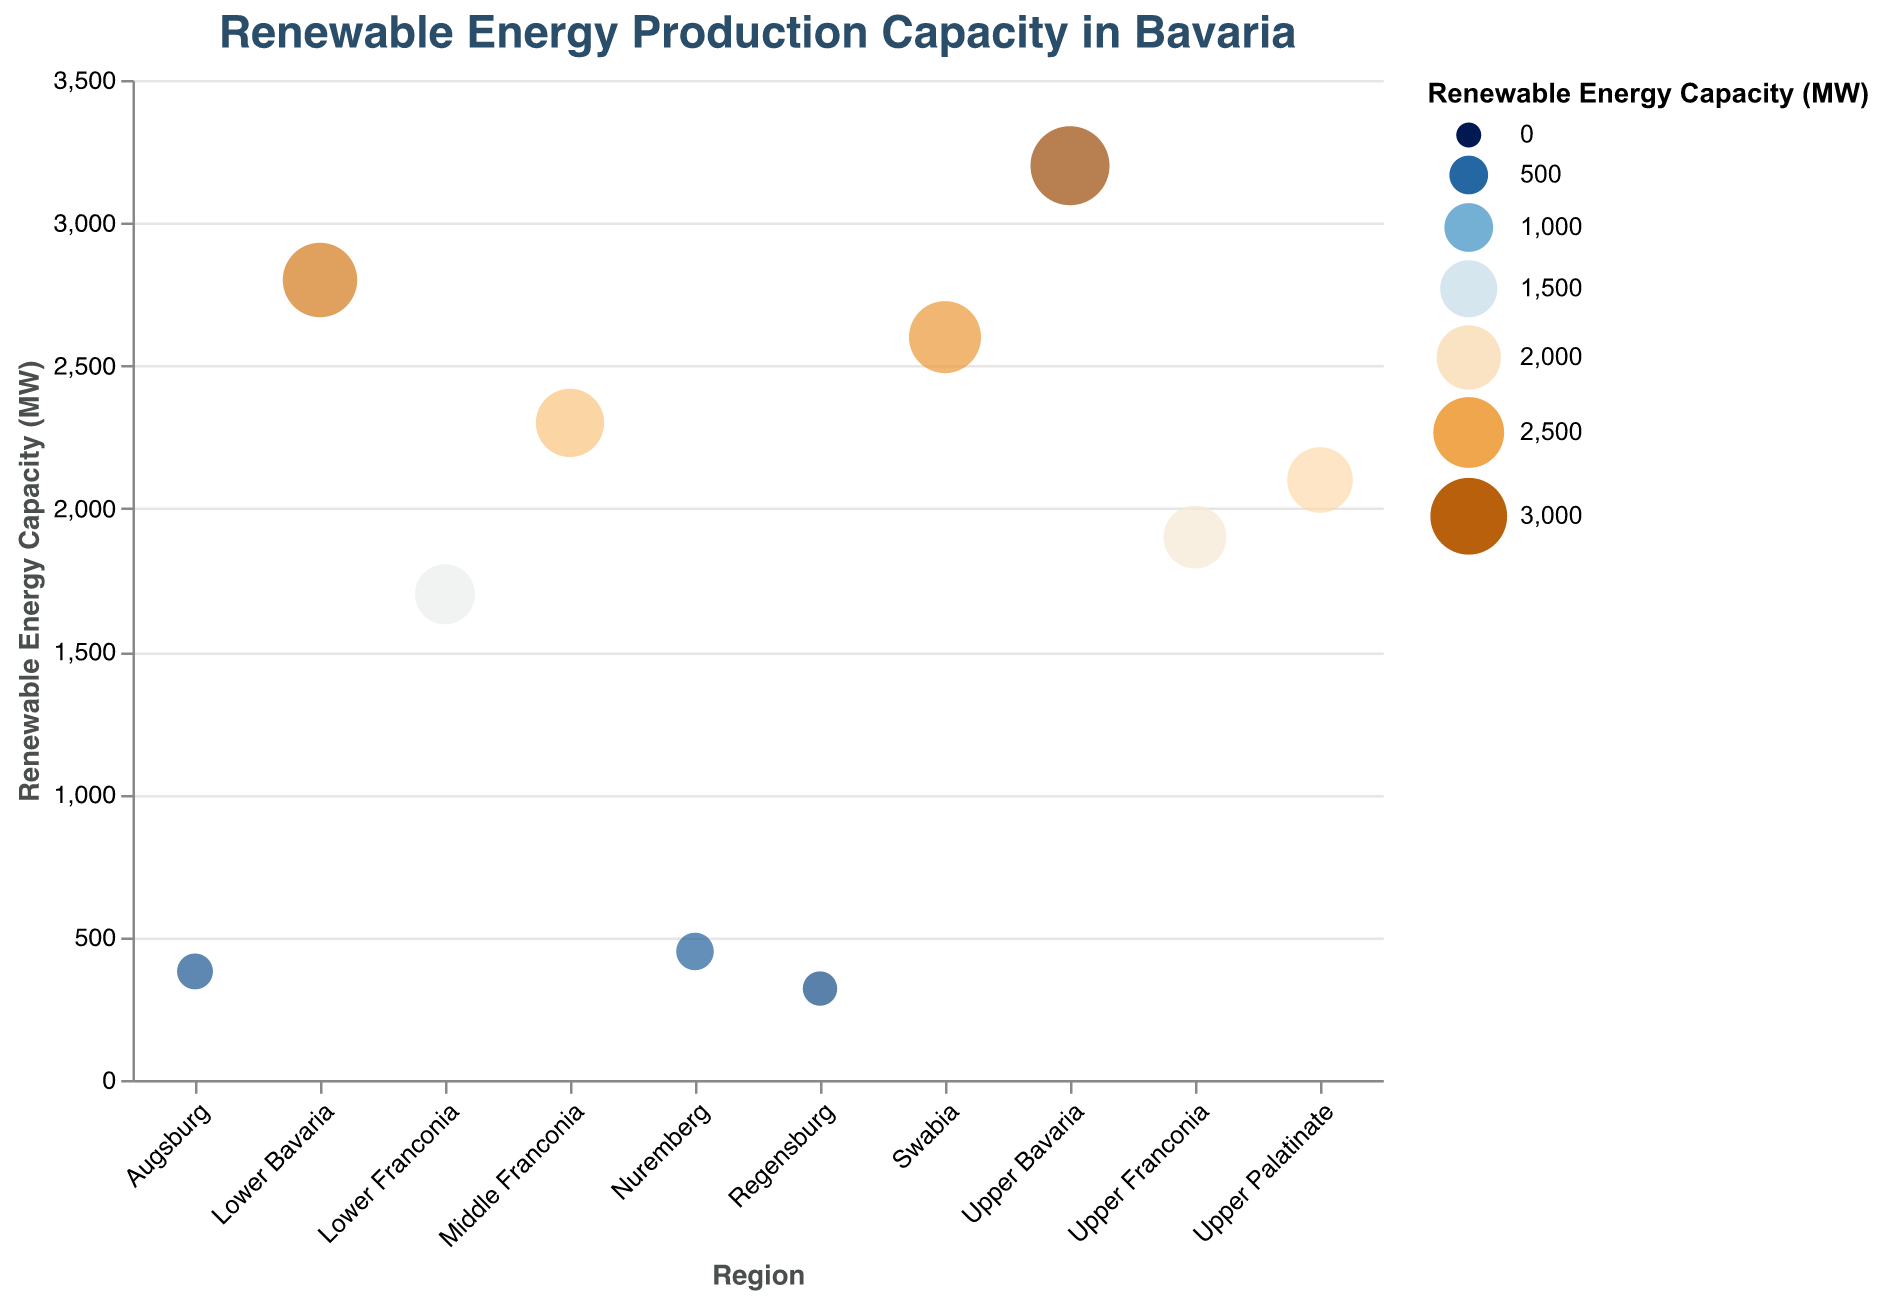What is the title of the figure? The title of the figure is displayed at the top and typically explains what the plot is about.
Answer: Renewable Energy Production Capacity in Bavaria How many regions are represented in the figure? Counting the number of distinct regions mentioned in the x-axis of the figure will give this number. The data list 10 unique regions.
Answer: 10 Which region has the highest renewable energy capacity? Inspect the y-axis values and find the region with the highest value. In this plot, Upper Bavaria has the maximum capacity of 3200 MW.
Answer: Upper Bavaria What is the renewable energy capacity of Lower Franconia? Find Lower Franconia on the x-axis and refer to its corresponding y-axis value. It has a capacity of 1700 MW.
Answer: 1700 MW Which region has the lowest renewable energy capacity, and what is its capacity? Identify the region with the smallest value on the y-axis. Nuremberg has the lowest capacity at 450 MW.
Answer: Nuremberg; 450 MW What is the total renewable energy capacity of all regions combined? Sum the capacities of all the regions: 3200 + 2800 + 2100 + 1900 + 2300 + 1700 + 2600 + 450 + 380 + 320. The total is 17750 MW.
Answer: 17750 MW How many regions have a renewable energy capacity greater than 2000 MW? Identify the regions whose capacities on the y-axis exceed 2000 MW. These regions are Upper Bavaria, Lower Bavaria, Upper Palatinate, Middle Franconia, and Swabia. There are 5 such regions.
Answer: 5 What is the average renewable energy capacity of the regions? Calculate the sum of all capacities and divide by the number of regions: 17750 MW / 10 = 1775 MW.
Answer: 1775 MW Based on the plot, does Augsburg have more or less renewable energy capacity than Regensburg? Compare the y-axis values for Augsburg (380 MW) and Regensburg (320 MW). Augsburg has more capacity.
Answer: More 